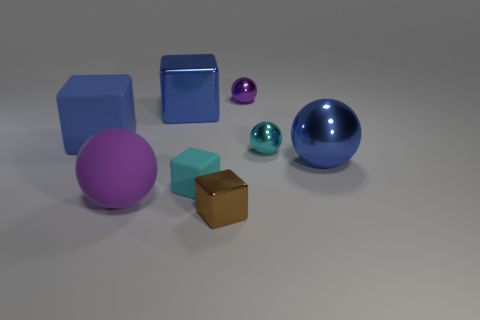Is the number of tiny cyan objects that are left of the big blue rubber object the same as the number of tiny cyan rubber things that are behind the purple matte object? Upon examining the image, it appears that the number of tiny cyan objects to the left of the big blue rubber object is not the same as the number of tiny cyan objects behind the purple matte object. Specifically, there is one tiny cyan object to the left of the blue rubber sphere while there are no cyan objects behind the purple matte cube. 